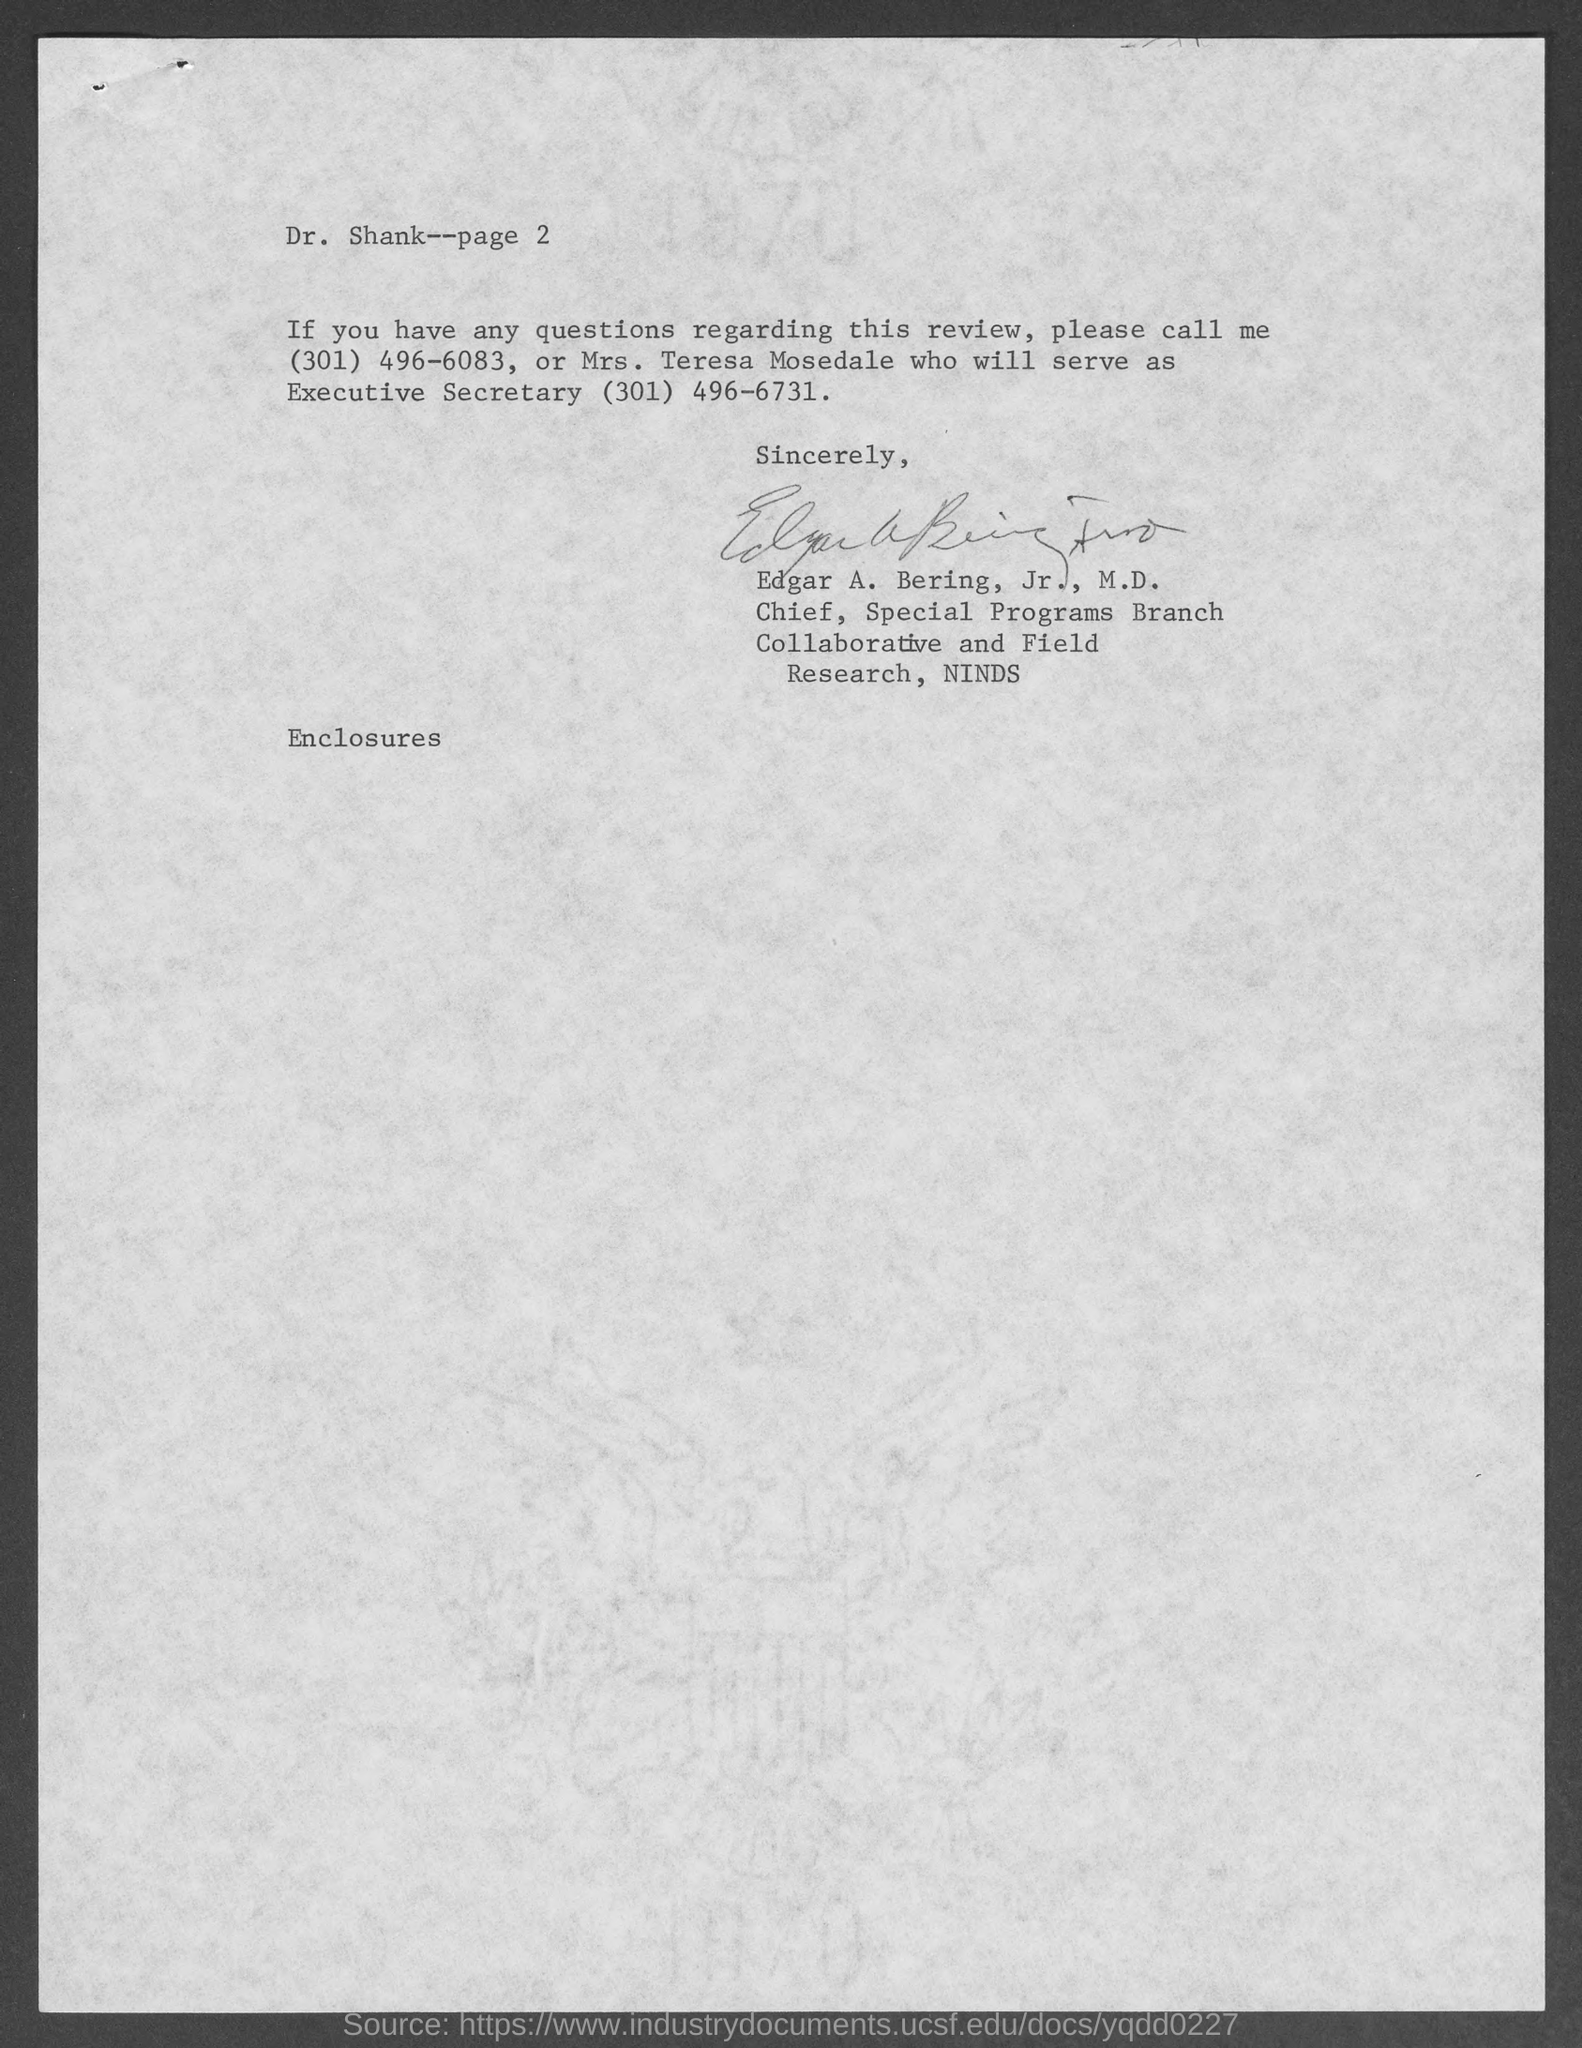What is the page number at top of the page?
Offer a very short reply. 2. Who is referred as you in this letter?
Offer a very short reply. Dr. Shank. Who wrote this letter?
Provide a succinct answer. Edgar A. Bering, Jr., M.D. 